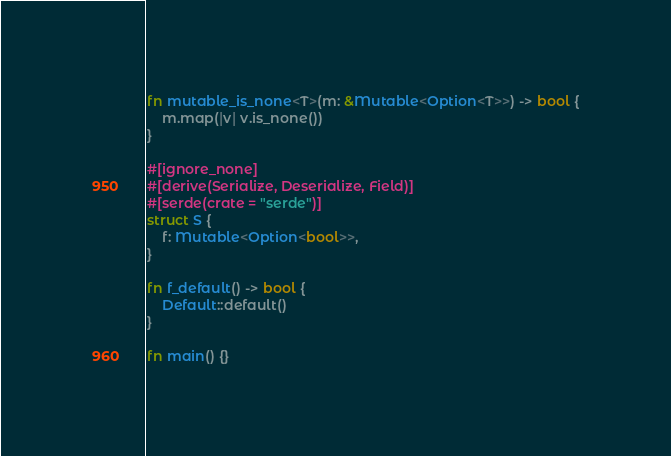<code> <loc_0><loc_0><loc_500><loc_500><_Rust_>fn mutable_is_none<T>(m: &Mutable<Option<T>>) -> bool {
    m.map(|v| v.is_none())
}

#[ignore_none]
#[derive(Serialize, Deserialize, Field)]
#[serde(crate = "serde")]
struct S {
    f: Mutable<Option<bool>>,
}

fn f_default() -> bool {
    Default::default()
}

fn main() {}
</code> 